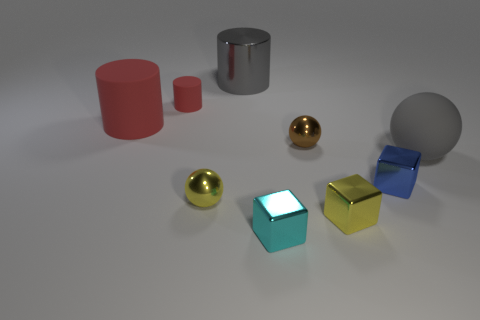Is there a big shiny object that has the same color as the small matte object? Indeed, there is no big shiny object having the same color as the small matte one. Observing the image, we see a variety of objects with different sizes, textures, and colors: shiny spheres, matte cubes, and both matte and reflective cylinders, but none of the larger shiny objects share their color with the smaller matte ones. 